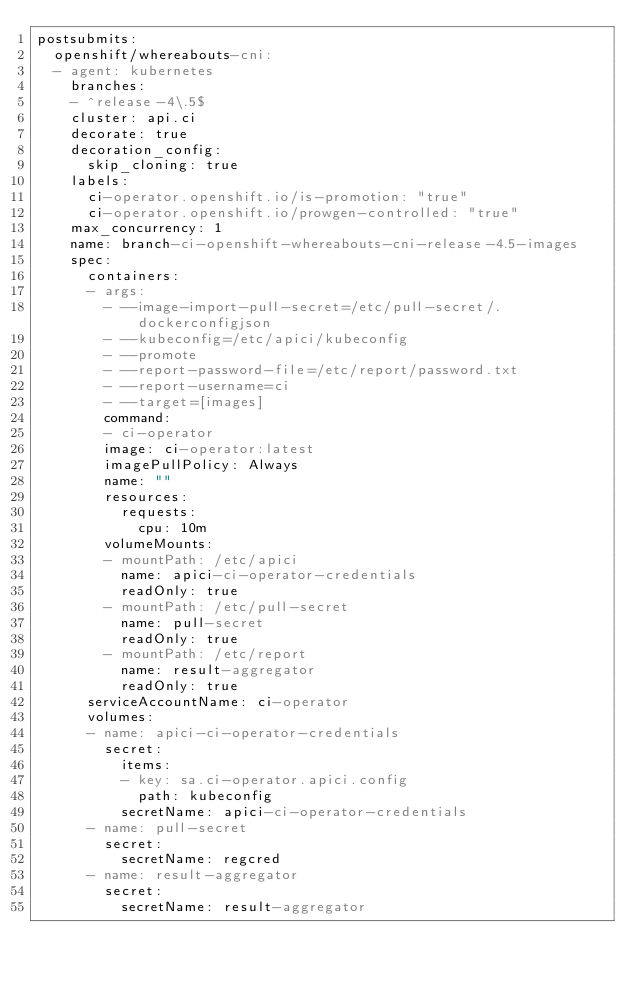Convert code to text. <code><loc_0><loc_0><loc_500><loc_500><_YAML_>postsubmits:
  openshift/whereabouts-cni:
  - agent: kubernetes
    branches:
    - ^release-4\.5$
    cluster: api.ci
    decorate: true
    decoration_config:
      skip_cloning: true
    labels:
      ci-operator.openshift.io/is-promotion: "true"
      ci-operator.openshift.io/prowgen-controlled: "true"
    max_concurrency: 1
    name: branch-ci-openshift-whereabouts-cni-release-4.5-images
    spec:
      containers:
      - args:
        - --image-import-pull-secret=/etc/pull-secret/.dockerconfigjson
        - --kubeconfig=/etc/apici/kubeconfig
        - --promote
        - --report-password-file=/etc/report/password.txt
        - --report-username=ci
        - --target=[images]
        command:
        - ci-operator
        image: ci-operator:latest
        imagePullPolicy: Always
        name: ""
        resources:
          requests:
            cpu: 10m
        volumeMounts:
        - mountPath: /etc/apici
          name: apici-ci-operator-credentials
          readOnly: true
        - mountPath: /etc/pull-secret
          name: pull-secret
          readOnly: true
        - mountPath: /etc/report
          name: result-aggregator
          readOnly: true
      serviceAccountName: ci-operator
      volumes:
      - name: apici-ci-operator-credentials
        secret:
          items:
          - key: sa.ci-operator.apici.config
            path: kubeconfig
          secretName: apici-ci-operator-credentials
      - name: pull-secret
        secret:
          secretName: regcred
      - name: result-aggregator
        secret:
          secretName: result-aggregator
</code> 